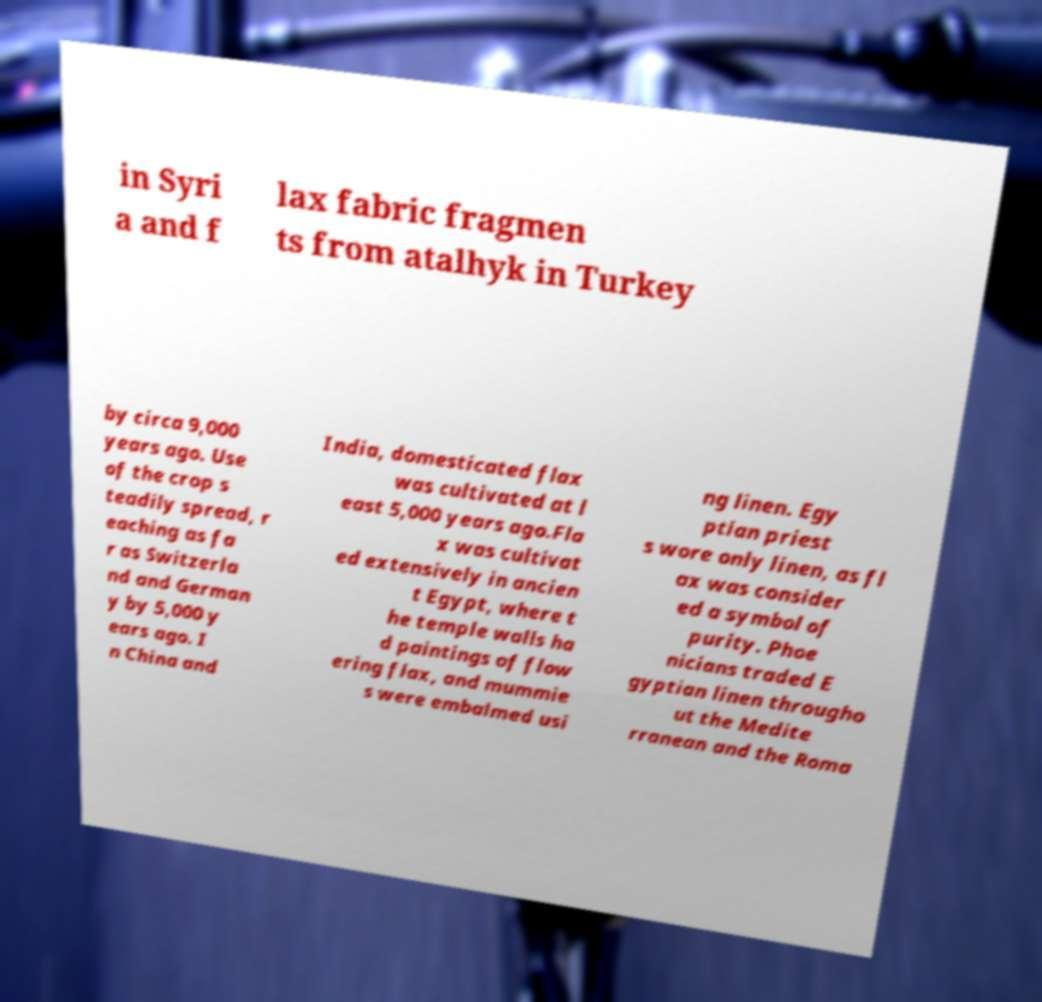Can you accurately transcribe the text from the provided image for me? in Syri a and f lax fabric fragmen ts from atalhyk in Turkey by circa 9,000 years ago. Use of the crop s teadily spread, r eaching as fa r as Switzerla nd and German y by 5,000 y ears ago. I n China and India, domesticated flax was cultivated at l east 5,000 years ago.Fla x was cultivat ed extensively in ancien t Egypt, where t he temple walls ha d paintings of flow ering flax, and mummie s were embalmed usi ng linen. Egy ptian priest s wore only linen, as fl ax was consider ed a symbol of purity. Phoe nicians traded E gyptian linen througho ut the Medite rranean and the Roma 